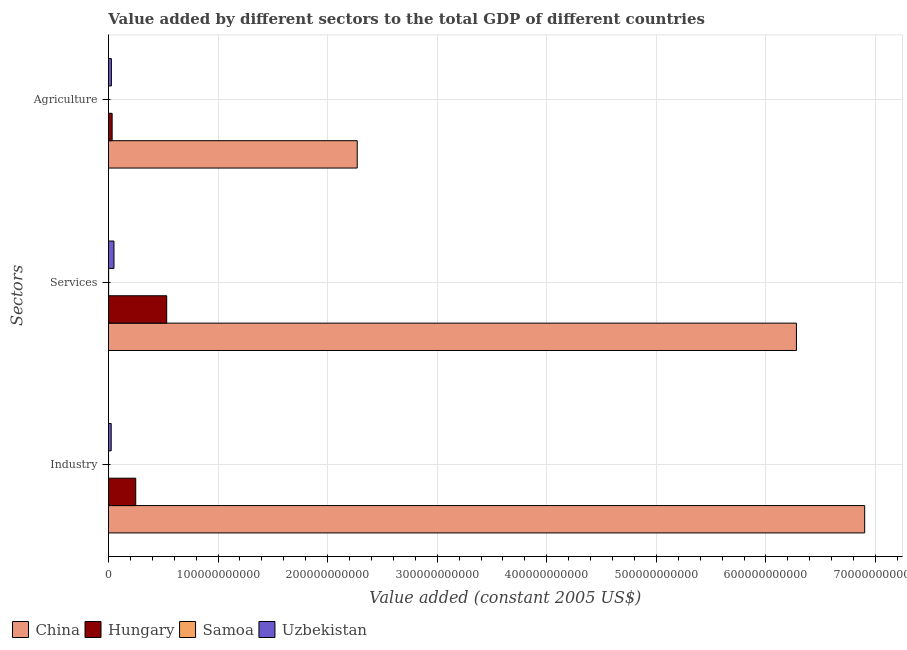How many groups of bars are there?
Give a very brief answer. 3. Are the number of bars per tick equal to the number of legend labels?
Provide a short and direct response. Yes. How many bars are there on the 1st tick from the top?
Ensure brevity in your answer.  4. How many bars are there on the 2nd tick from the bottom?
Give a very brief answer. 4. What is the label of the 3rd group of bars from the top?
Provide a succinct answer. Industry. What is the value added by industrial sector in Uzbekistan?
Make the answer very short. 2.52e+09. Across all countries, what is the maximum value added by agricultural sector?
Provide a short and direct response. 2.27e+11. Across all countries, what is the minimum value added by agricultural sector?
Your answer should be compact. 6.30e+07. In which country was the value added by agricultural sector maximum?
Give a very brief answer. China. In which country was the value added by agricultural sector minimum?
Keep it short and to the point. Samoa. What is the total value added by agricultural sector in the graph?
Make the answer very short. 2.33e+11. What is the difference between the value added by services in Uzbekistan and that in Hungary?
Give a very brief answer. -4.81e+1. What is the difference between the value added by services in Samoa and the value added by agricultural sector in Uzbekistan?
Your response must be concise. -2.49e+09. What is the average value added by industrial sector per country?
Your response must be concise. 1.79e+11. What is the difference between the value added by agricultural sector and value added by services in China?
Make the answer very short. -4.01e+11. What is the ratio of the value added by services in China to that in Samoa?
Your answer should be compact. 2944.9. Is the value added by agricultural sector in Hungary less than that in Uzbekistan?
Provide a short and direct response. No. Is the difference between the value added by services in China and Uzbekistan greater than the difference between the value added by agricultural sector in China and Uzbekistan?
Your answer should be compact. Yes. What is the difference between the highest and the second highest value added by industrial sector?
Provide a short and direct response. 6.65e+11. What is the difference between the highest and the lowest value added by agricultural sector?
Ensure brevity in your answer.  2.27e+11. Is the sum of the value added by industrial sector in Samoa and Uzbekistan greater than the maximum value added by services across all countries?
Your answer should be very brief. No. What does the 4th bar from the bottom in Industry represents?
Give a very brief answer. Uzbekistan. Is it the case that in every country, the sum of the value added by industrial sector and value added by services is greater than the value added by agricultural sector?
Ensure brevity in your answer.  Yes. Are all the bars in the graph horizontal?
Ensure brevity in your answer.  Yes. How many countries are there in the graph?
Your answer should be compact. 4. What is the difference between two consecutive major ticks on the X-axis?
Ensure brevity in your answer.  1.00e+11. Are the values on the major ticks of X-axis written in scientific E-notation?
Your answer should be compact. No. Does the graph contain any zero values?
Keep it short and to the point. No. How are the legend labels stacked?
Offer a terse response. Horizontal. What is the title of the graph?
Provide a succinct answer. Value added by different sectors to the total GDP of different countries. What is the label or title of the X-axis?
Keep it short and to the point. Value added (constant 2005 US$). What is the label or title of the Y-axis?
Your response must be concise. Sectors. What is the Value added (constant 2005 US$) in China in Industry?
Your answer should be compact. 6.90e+11. What is the Value added (constant 2005 US$) in Hungary in Industry?
Keep it short and to the point. 2.49e+1. What is the Value added (constant 2005 US$) in Samoa in Industry?
Provide a short and direct response. 1.09e+08. What is the Value added (constant 2005 US$) in Uzbekistan in Industry?
Your answer should be compact. 2.52e+09. What is the Value added (constant 2005 US$) of China in Services?
Your answer should be compact. 6.28e+11. What is the Value added (constant 2005 US$) of Hungary in Services?
Keep it short and to the point. 5.32e+1. What is the Value added (constant 2005 US$) in Samoa in Services?
Make the answer very short. 2.13e+08. What is the Value added (constant 2005 US$) in Uzbekistan in Services?
Your answer should be very brief. 5.05e+09. What is the Value added (constant 2005 US$) in China in Agriculture?
Ensure brevity in your answer.  2.27e+11. What is the Value added (constant 2005 US$) in Hungary in Agriculture?
Ensure brevity in your answer.  3.39e+09. What is the Value added (constant 2005 US$) in Samoa in Agriculture?
Keep it short and to the point. 6.30e+07. What is the Value added (constant 2005 US$) of Uzbekistan in Agriculture?
Keep it short and to the point. 2.70e+09. Across all Sectors, what is the maximum Value added (constant 2005 US$) in China?
Keep it short and to the point. 6.90e+11. Across all Sectors, what is the maximum Value added (constant 2005 US$) in Hungary?
Your answer should be very brief. 5.32e+1. Across all Sectors, what is the maximum Value added (constant 2005 US$) in Samoa?
Your answer should be compact. 2.13e+08. Across all Sectors, what is the maximum Value added (constant 2005 US$) in Uzbekistan?
Make the answer very short. 5.05e+09. Across all Sectors, what is the minimum Value added (constant 2005 US$) of China?
Make the answer very short. 2.27e+11. Across all Sectors, what is the minimum Value added (constant 2005 US$) of Hungary?
Offer a very short reply. 3.39e+09. Across all Sectors, what is the minimum Value added (constant 2005 US$) of Samoa?
Make the answer very short. 6.30e+07. Across all Sectors, what is the minimum Value added (constant 2005 US$) in Uzbekistan?
Offer a very short reply. 2.52e+09. What is the total Value added (constant 2005 US$) in China in the graph?
Offer a very short reply. 1.55e+12. What is the total Value added (constant 2005 US$) in Hungary in the graph?
Offer a terse response. 8.15e+1. What is the total Value added (constant 2005 US$) of Samoa in the graph?
Offer a terse response. 3.85e+08. What is the total Value added (constant 2005 US$) of Uzbekistan in the graph?
Your answer should be very brief. 1.03e+1. What is the difference between the Value added (constant 2005 US$) of China in Industry and that in Services?
Give a very brief answer. 6.23e+1. What is the difference between the Value added (constant 2005 US$) in Hungary in Industry and that in Services?
Provide a short and direct response. -2.83e+1. What is the difference between the Value added (constant 2005 US$) of Samoa in Industry and that in Services?
Make the answer very short. -1.05e+08. What is the difference between the Value added (constant 2005 US$) of Uzbekistan in Industry and that in Services?
Offer a very short reply. -2.54e+09. What is the difference between the Value added (constant 2005 US$) in China in Industry and that in Agriculture?
Offer a terse response. 4.63e+11. What is the difference between the Value added (constant 2005 US$) in Hungary in Industry and that in Agriculture?
Your response must be concise. 2.15e+1. What is the difference between the Value added (constant 2005 US$) in Samoa in Industry and that in Agriculture?
Ensure brevity in your answer.  4.55e+07. What is the difference between the Value added (constant 2005 US$) in Uzbekistan in Industry and that in Agriculture?
Your response must be concise. -1.84e+08. What is the difference between the Value added (constant 2005 US$) in China in Services and that in Agriculture?
Your response must be concise. 4.01e+11. What is the difference between the Value added (constant 2005 US$) of Hungary in Services and that in Agriculture?
Your answer should be compact. 4.98e+1. What is the difference between the Value added (constant 2005 US$) of Samoa in Services and that in Agriculture?
Your response must be concise. 1.50e+08. What is the difference between the Value added (constant 2005 US$) of Uzbekistan in Services and that in Agriculture?
Your answer should be very brief. 2.35e+09. What is the difference between the Value added (constant 2005 US$) in China in Industry and the Value added (constant 2005 US$) in Hungary in Services?
Keep it short and to the point. 6.37e+11. What is the difference between the Value added (constant 2005 US$) in China in Industry and the Value added (constant 2005 US$) in Samoa in Services?
Give a very brief answer. 6.90e+11. What is the difference between the Value added (constant 2005 US$) in China in Industry and the Value added (constant 2005 US$) in Uzbekistan in Services?
Give a very brief answer. 6.85e+11. What is the difference between the Value added (constant 2005 US$) of Hungary in Industry and the Value added (constant 2005 US$) of Samoa in Services?
Keep it short and to the point. 2.47e+1. What is the difference between the Value added (constant 2005 US$) in Hungary in Industry and the Value added (constant 2005 US$) in Uzbekistan in Services?
Offer a terse response. 1.99e+1. What is the difference between the Value added (constant 2005 US$) of Samoa in Industry and the Value added (constant 2005 US$) of Uzbekistan in Services?
Give a very brief answer. -4.95e+09. What is the difference between the Value added (constant 2005 US$) of China in Industry and the Value added (constant 2005 US$) of Hungary in Agriculture?
Offer a very short reply. 6.87e+11. What is the difference between the Value added (constant 2005 US$) in China in Industry and the Value added (constant 2005 US$) in Samoa in Agriculture?
Your answer should be very brief. 6.90e+11. What is the difference between the Value added (constant 2005 US$) of China in Industry and the Value added (constant 2005 US$) of Uzbekistan in Agriculture?
Offer a terse response. 6.87e+11. What is the difference between the Value added (constant 2005 US$) of Hungary in Industry and the Value added (constant 2005 US$) of Samoa in Agriculture?
Your answer should be very brief. 2.49e+1. What is the difference between the Value added (constant 2005 US$) in Hungary in Industry and the Value added (constant 2005 US$) in Uzbekistan in Agriculture?
Your answer should be very brief. 2.22e+1. What is the difference between the Value added (constant 2005 US$) in Samoa in Industry and the Value added (constant 2005 US$) in Uzbekistan in Agriculture?
Your answer should be compact. -2.59e+09. What is the difference between the Value added (constant 2005 US$) of China in Services and the Value added (constant 2005 US$) of Hungary in Agriculture?
Offer a terse response. 6.24e+11. What is the difference between the Value added (constant 2005 US$) of China in Services and the Value added (constant 2005 US$) of Samoa in Agriculture?
Provide a short and direct response. 6.28e+11. What is the difference between the Value added (constant 2005 US$) in China in Services and the Value added (constant 2005 US$) in Uzbekistan in Agriculture?
Give a very brief answer. 6.25e+11. What is the difference between the Value added (constant 2005 US$) of Hungary in Services and the Value added (constant 2005 US$) of Samoa in Agriculture?
Ensure brevity in your answer.  5.31e+1. What is the difference between the Value added (constant 2005 US$) in Hungary in Services and the Value added (constant 2005 US$) in Uzbekistan in Agriculture?
Give a very brief answer. 5.05e+1. What is the difference between the Value added (constant 2005 US$) of Samoa in Services and the Value added (constant 2005 US$) of Uzbekistan in Agriculture?
Your answer should be compact. -2.49e+09. What is the average Value added (constant 2005 US$) of China per Sectors?
Your answer should be compact. 5.15e+11. What is the average Value added (constant 2005 US$) of Hungary per Sectors?
Your answer should be compact. 2.72e+1. What is the average Value added (constant 2005 US$) of Samoa per Sectors?
Keep it short and to the point. 1.28e+08. What is the average Value added (constant 2005 US$) of Uzbekistan per Sectors?
Offer a very short reply. 3.42e+09. What is the difference between the Value added (constant 2005 US$) of China and Value added (constant 2005 US$) of Hungary in Industry?
Your response must be concise. 6.65e+11. What is the difference between the Value added (constant 2005 US$) in China and Value added (constant 2005 US$) in Samoa in Industry?
Ensure brevity in your answer.  6.90e+11. What is the difference between the Value added (constant 2005 US$) of China and Value added (constant 2005 US$) of Uzbekistan in Industry?
Your answer should be very brief. 6.88e+11. What is the difference between the Value added (constant 2005 US$) in Hungary and Value added (constant 2005 US$) in Samoa in Industry?
Your answer should be compact. 2.48e+1. What is the difference between the Value added (constant 2005 US$) of Hungary and Value added (constant 2005 US$) of Uzbekistan in Industry?
Keep it short and to the point. 2.24e+1. What is the difference between the Value added (constant 2005 US$) of Samoa and Value added (constant 2005 US$) of Uzbekistan in Industry?
Provide a short and direct response. -2.41e+09. What is the difference between the Value added (constant 2005 US$) in China and Value added (constant 2005 US$) in Hungary in Services?
Provide a succinct answer. 5.75e+11. What is the difference between the Value added (constant 2005 US$) of China and Value added (constant 2005 US$) of Samoa in Services?
Provide a succinct answer. 6.28e+11. What is the difference between the Value added (constant 2005 US$) of China and Value added (constant 2005 US$) of Uzbekistan in Services?
Offer a terse response. 6.23e+11. What is the difference between the Value added (constant 2005 US$) of Hungary and Value added (constant 2005 US$) of Samoa in Services?
Provide a short and direct response. 5.30e+1. What is the difference between the Value added (constant 2005 US$) of Hungary and Value added (constant 2005 US$) of Uzbekistan in Services?
Your response must be concise. 4.81e+1. What is the difference between the Value added (constant 2005 US$) of Samoa and Value added (constant 2005 US$) of Uzbekistan in Services?
Make the answer very short. -4.84e+09. What is the difference between the Value added (constant 2005 US$) in China and Value added (constant 2005 US$) in Hungary in Agriculture?
Give a very brief answer. 2.24e+11. What is the difference between the Value added (constant 2005 US$) of China and Value added (constant 2005 US$) of Samoa in Agriculture?
Provide a succinct answer. 2.27e+11. What is the difference between the Value added (constant 2005 US$) of China and Value added (constant 2005 US$) of Uzbekistan in Agriculture?
Offer a very short reply. 2.24e+11. What is the difference between the Value added (constant 2005 US$) in Hungary and Value added (constant 2005 US$) in Samoa in Agriculture?
Make the answer very short. 3.32e+09. What is the difference between the Value added (constant 2005 US$) of Hungary and Value added (constant 2005 US$) of Uzbekistan in Agriculture?
Keep it short and to the point. 6.84e+08. What is the difference between the Value added (constant 2005 US$) in Samoa and Value added (constant 2005 US$) in Uzbekistan in Agriculture?
Provide a succinct answer. -2.64e+09. What is the ratio of the Value added (constant 2005 US$) in China in Industry to that in Services?
Offer a terse response. 1.1. What is the ratio of the Value added (constant 2005 US$) of Hungary in Industry to that in Services?
Ensure brevity in your answer.  0.47. What is the ratio of the Value added (constant 2005 US$) in Samoa in Industry to that in Services?
Your response must be concise. 0.51. What is the ratio of the Value added (constant 2005 US$) of Uzbekistan in Industry to that in Services?
Give a very brief answer. 0.5. What is the ratio of the Value added (constant 2005 US$) in China in Industry to that in Agriculture?
Your answer should be compact. 3.04. What is the ratio of the Value added (constant 2005 US$) of Hungary in Industry to that in Agriculture?
Ensure brevity in your answer.  7.36. What is the ratio of the Value added (constant 2005 US$) of Samoa in Industry to that in Agriculture?
Your response must be concise. 1.72. What is the ratio of the Value added (constant 2005 US$) in Uzbekistan in Industry to that in Agriculture?
Provide a succinct answer. 0.93. What is the ratio of the Value added (constant 2005 US$) in China in Services to that in Agriculture?
Offer a very short reply. 2.77. What is the ratio of the Value added (constant 2005 US$) of Hungary in Services to that in Agriculture?
Provide a short and direct response. 15.7. What is the ratio of the Value added (constant 2005 US$) in Samoa in Services to that in Agriculture?
Offer a very short reply. 3.38. What is the ratio of the Value added (constant 2005 US$) of Uzbekistan in Services to that in Agriculture?
Offer a very short reply. 1.87. What is the difference between the highest and the second highest Value added (constant 2005 US$) of China?
Give a very brief answer. 6.23e+1. What is the difference between the highest and the second highest Value added (constant 2005 US$) in Hungary?
Offer a terse response. 2.83e+1. What is the difference between the highest and the second highest Value added (constant 2005 US$) in Samoa?
Make the answer very short. 1.05e+08. What is the difference between the highest and the second highest Value added (constant 2005 US$) of Uzbekistan?
Provide a succinct answer. 2.35e+09. What is the difference between the highest and the lowest Value added (constant 2005 US$) in China?
Provide a succinct answer. 4.63e+11. What is the difference between the highest and the lowest Value added (constant 2005 US$) in Hungary?
Your answer should be compact. 4.98e+1. What is the difference between the highest and the lowest Value added (constant 2005 US$) in Samoa?
Provide a short and direct response. 1.50e+08. What is the difference between the highest and the lowest Value added (constant 2005 US$) of Uzbekistan?
Offer a very short reply. 2.54e+09. 